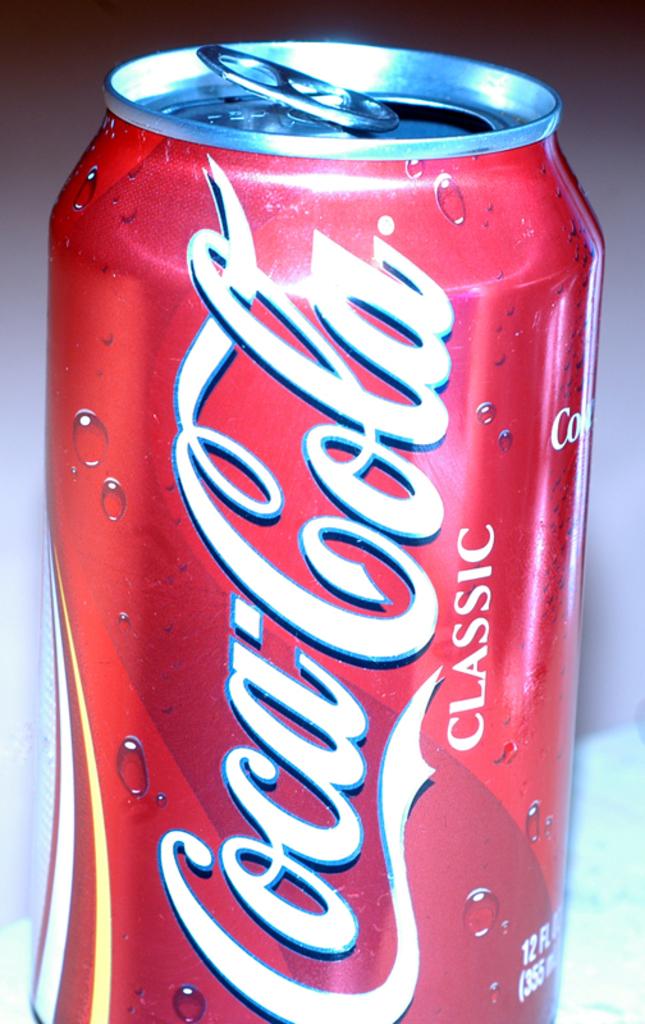What brand is this?
Offer a terse response. Coca-cola. 